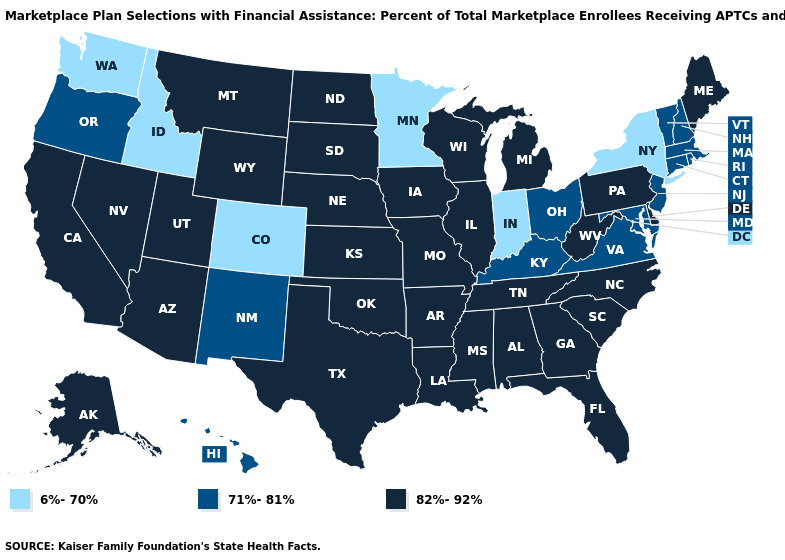Name the states that have a value in the range 71%-81%?
Keep it brief. Connecticut, Hawaii, Kentucky, Maryland, Massachusetts, New Hampshire, New Jersey, New Mexico, Ohio, Oregon, Rhode Island, Vermont, Virginia. How many symbols are there in the legend?
Give a very brief answer. 3. What is the lowest value in states that border Arkansas?
Give a very brief answer. 82%-92%. What is the highest value in states that border Pennsylvania?
Concise answer only. 82%-92%. What is the lowest value in the USA?
Write a very short answer. 6%-70%. What is the lowest value in the USA?
Quick response, please. 6%-70%. Among the states that border Colorado , which have the lowest value?
Quick response, please. New Mexico. Is the legend a continuous bar?
Be succinct. No. Does the first symbol in the legend represent the smallest category?
Answer briefly. Yes. Which states have the lowest value in the MidWest?
Concise answer only. Indiana, Minnesota. How many symbols are there in the legend?
Quick response, please. 3. What is the highest value in the Northeast ?
Give a very brief answer. 82%-92%. What is the value of Oklahoma?
Concise answer only. 82%-92%. Name the states that have a value in the range 82%-92%?
Short answer required. Alabama, Alaska, Arizona, Arkansas, California, Delaware, Florida, Georgia, Illinois, Iowa, Kansas, Louisiana, Maine, Michigan, Mississippi, Missouri, Montana, Nebraska, Nevada, North Carolina, North Dakota, Oklahoma, Pennsylvania, South Carolina, South Dakota, Tennessee, Texas, Utah, West Virginia, Wisconsin, Wyoming. Name the states that have a value in the range 6%-70%?
Give a very brief answer. Colorado, Idaho, Indiana, Minnesota, New York, Washington. 